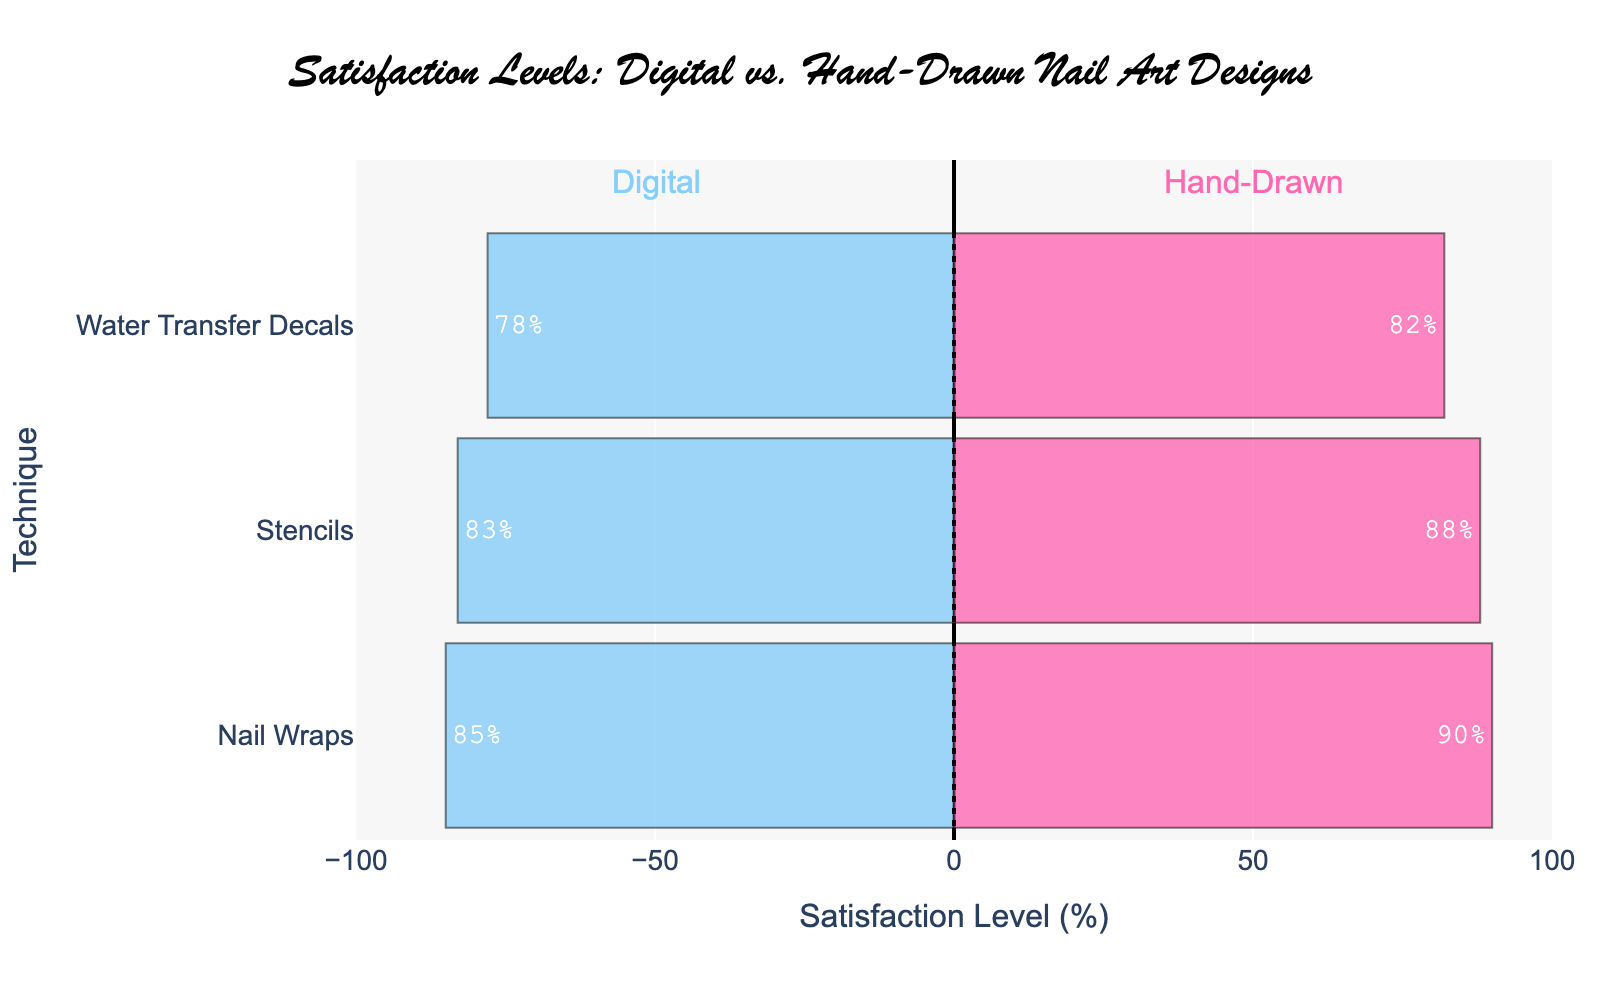what is the highest satisfaction level for hand-drawn techniques? The highest satisfaction level among hand-drawn techniques can be observed by looking for the tallest bar on the positive side of the diverging bar chart, which represents the hand-drawn techniques. "Hand-Drawn Nail Wraps" has the longest bar reaching a satisfaction level of 90.
Answer: 90 which technique has the lowest satisfaction level among digital designs? The lowest satisfaction level among digital designs can be found by identifying the shortest bar on the negative side of the diverging bar chart. "Water Transfer Decals" in digital design has the lowest satisfaction level of 78.
Answer: Water Transfer Decals how much higher is the satisfaction level for hand-drawn stencils compared to digital stencils? To find the difference in satisfaction levels, subtract the satisfaction level of digital stencils from that of hand-drawn stencils. Hand-drawn stencils have a satisfaction level of 88 whereas digital stencils have 83. Hence, the difference is 88 - 83 = 5%.
Answer: 5% what is the average satisfaction level for digital designs? Calculate the average by summing up the satisfaction levels for all digital designs (85 + 78 + 83) and then dividing by the number of techniques. (85 + 78 + 83) / 3 = 246 / 3 = 82
Answer: 82 is the satisfaction level for hand-drawn water transfer decals higher or lower than the overall average satisfaction level? First, find the overall average satisfaction level by summing all satisfaction levels and dividing by the total number of techniques. (85 + 78 + 83 + 90 + 82 + 88) / 6 = 506 / 6 = 84.33. The satisfaction level for hand-drawn water transfer decals is 82, which is slightly lower than the overall average satisfaction level of 84.33.
Answer: lower are there more techniques with satisfaction levels above 85 or below 85? Count the number of techniques with satisfaction levels above and below 85. Techniques above 85: Digital Nail Wraps (85), Hand-Drawn Nail Wraps (90), and Hand-Drawn Stencils (88). Techniques below 85: Digital Water Transfer Decals (78), Digital Stencils (83), and Hand-Drawn Water Transfer Decals (82). Both categories have 3 techniques, so they are equal.
Answer: equal which technique shows the biggest difference in satisfaction level between hand-drawn and digital? To determine the biggest difference, calculate the differences for each technique and compare them. Nail Wraps: 90 - 85 = 5. Water Transfer Decals: 82 - 78 = 4. Stencils: 88 - 83 = 5. Both Nail Wraps and Stencils have the largest difference of 5%.
Answer: Nail Wraps and Stencils what color represents digital designs in the chart? By observing the color coding in the diverging bar chart, digital designs are represented by a light blue color.
Answer: light blue which hand-drawn technique has the smallest difference in satisfaction level compared to its digital counterpart? Calculate the satisfaction level differences for each pair of digital and hand-drawn techniques. Nail Wraps: 90 - 85 = 5. Water Transfer Decals: 82 - 78 = 4. Stencils: 88 - 83 = 5. Water Transfer Decals has the smallest difference of 4%.
Answer: Water Transfer Decals how many techniques have satisfaction levels above 80 for hand-drawn designs? Count the number of hand-drawn techniques with satisfaction levels above 80. The hand-drawn techniques and their satisfaction levels are: Nail Wraps (90), Water Transfer Decals (82), and Stencils (88). All three techniques have satisfaction levels above 80.
Answer: 3 